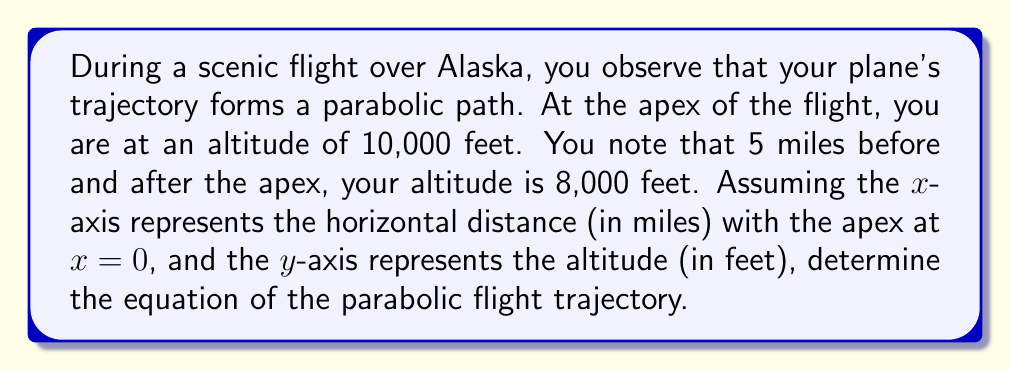Give your solution to this math problem. Let's approach this step-by-step:

1) The general equation of a parabola with a vertical axis of symmetry is:
   $$y = a(x-h)^2 + k$$
   where (h,k) is the vertex of the parabola.

2) We know the vertex is at (0, 10000), so h = 0 and k = 10000.
   Our equation becomes:
   $$y = ax^2 + 10000$$

3) We also know that when x = 5 and x = -5, y = 8000.
   Let's use this information:
   $$8000 = a(5)^2 + 10000$$

4) Simplify:
   $$8000 = 25a + 10000$$

5) Subtract 10000 from both sides:
   $$-2000 = 25a$$

6) Divide both sides by 25:
   $$a = -\frac{2000}{25} = -80$$

7) Now we have our value for a. Let's substitute it back into our equation:
   $$y = -80x^2 + 10000$$

This is the equation of the parabolic flight trajectory.
Answer: $y = -80x^2 + 10000$ 